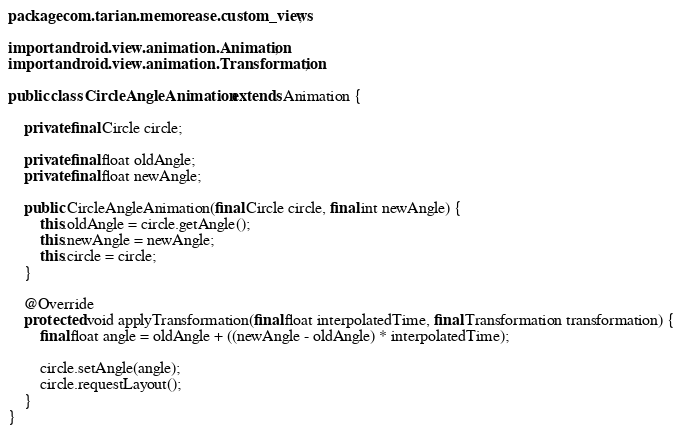Convert code to text. <code><loc_0><loc_0><loc_500><loc_500><_Java_>package com.tarian.memorease.custom_views;

import android.view.animation.Animation;
import android.view.animation.Transformation;

public class CircleAngleAnimation extends Animation {

    private final Circle circle;

    private final float oldAngle;
    private final float newAngle;

    public CircleAngleAnimation(final Circle circle, final int newAngle) {
        this.oldAngle = circle.getAngle();
        this.newAngle = newAngle;
        this.circle = circle;
    }

    @Override
    protected void applyTransformation(final float interpolatedTime, final Transformation transformation) {
        final float angle = oldAngle + ((newAngle - oldAngle) * interpolatedTime);

        circle.setAngle(angle);
        circle.requestLayout();
    }
}
</code> 